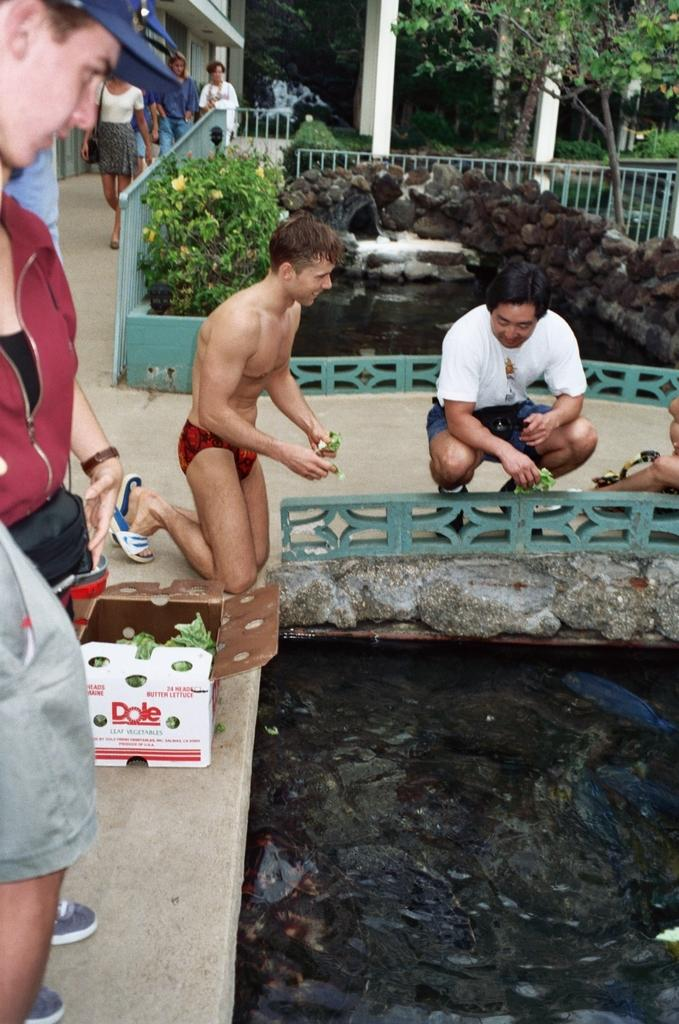What are the people holding in the image? The people are holding something thin in the image. What is happening to the thin objects? The thin objects are being thrown into water. What can be seen in the background of the image? There are buildings and trees visible in the background of the image. What else is happening in the background of the image? There are people walking in the background of the image. Where is the shelf located in the image? There is no shelf present in the image. Who is the partner of the person walking in the background of the image? There is no information about a partner for the person walking in the background of the image. 